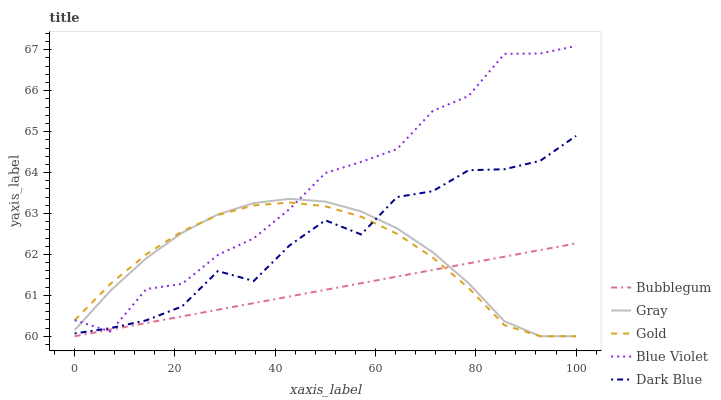Does Bubblegum have the minimum area under the curve?
Answer yes or no. Yes. Does Blue Violet have the maximum area under the curve?
Answer yes or no. Yes. Does Gray have the minimum area under the curve?
Answer yes or no. No. Does Gray have the maximum area under the curve?
Answer yes or no. No. Is Bubblegum the smoothest?
Answer yes or no. Yes. Is Dark Blue the roughest?
Answer yes or no. Yes. Is Gray the smoothest?
Answer yes or no. No. Is Gray the roughest?
Answer yes or no. No. Does Gray have the lowest value?
Answer yes or no. Yes. Does Dark Blue have the lowest value?
Answer yes or no. No. Does Blue Violet have the highest value?
Answer yes or no. Yes. Does Gray have the highest value?
Answer yes or no. No. Is Bubblegum less than Dark Blue?
Answer yes or no. Yes. Is Dark Blue greater than Bubblegum?
Answer yes or no. Yes. Does Blue Violet intersect Gold?
Answer yes or no. Yes. Is Blue Violet less than Gold?
Answer yes or no. No. Is Blue Violet greater than Gold?
Answer yes or no. No. Does Bubblegum intersect Dark Blue?
Answer yes or no. No. 